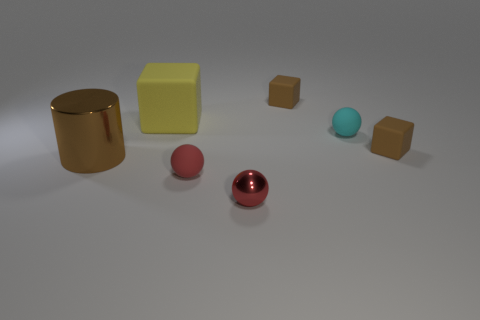Is the number of tiny matte balls behind the red rubber sphere the same as the number of tiny red matte spheres? Indeed, the number of tiny matte balls situated behind the red rubber sphere is equivalent to the number of tiny red matte spheres present in the scene, maintaining a balance in the composition through this subtle repetition of elements. 